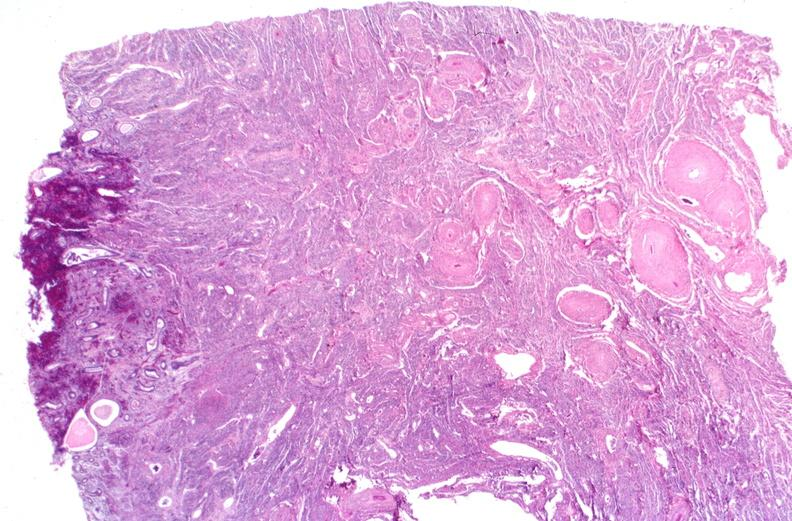what does this image show?
Answer the question using a single word or phrase. Kidney 